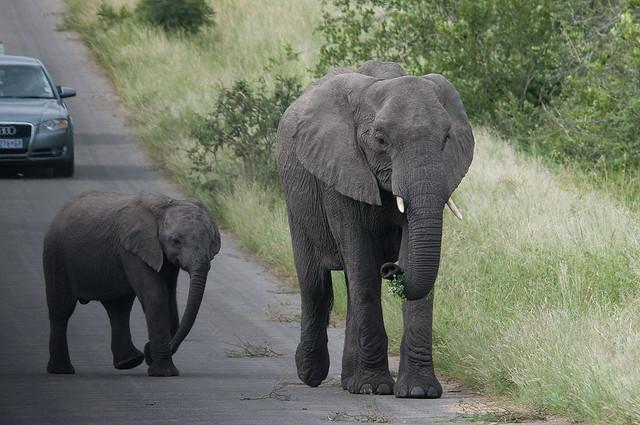What movie character fits in with these animals? dumbo 